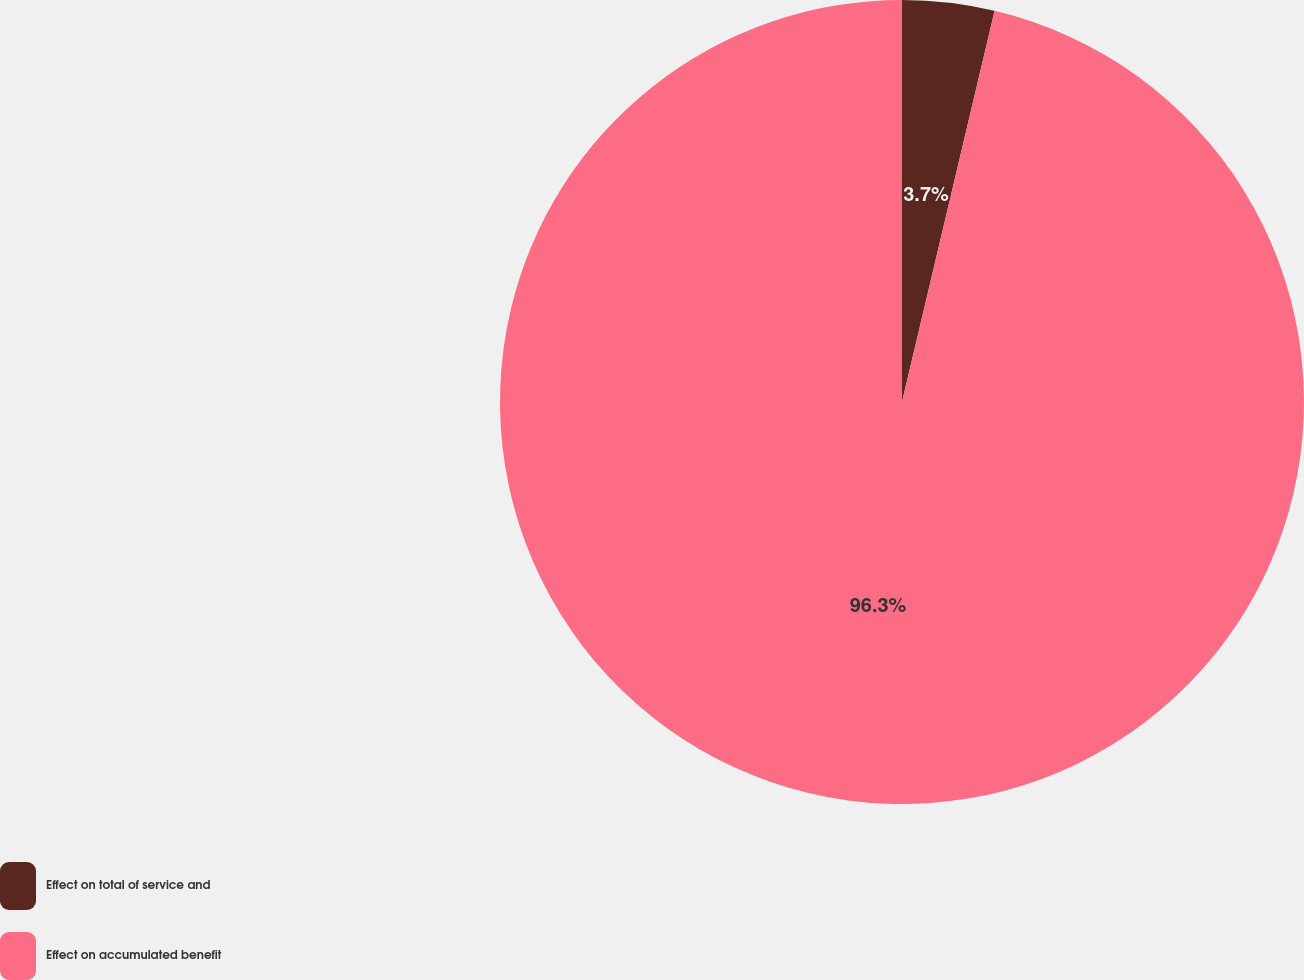<chart> <loc_0><loc_0><loc_500><loc_500><pie_chart><fcel>Effect on total of service and<fcel>Effect on accumulated benefit<nl><fcel>3.7%<fcel>96.3%<nl></chart> 